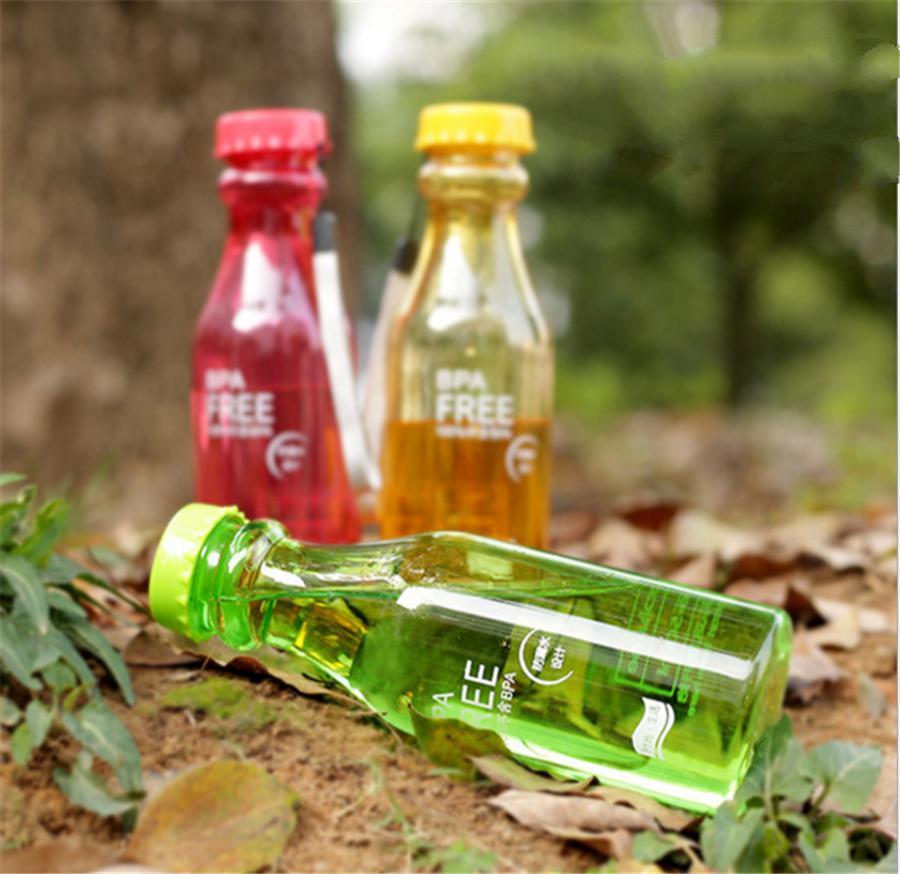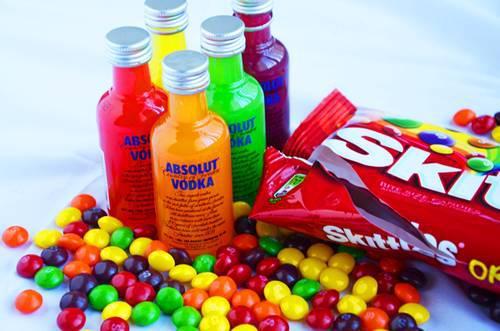The first image is the image on the left, the second image is the image on the right. Examine the images to the left and right. Is the description "The right image includes at least three upright bottles with multicolored candies on the surface next to them." accurate? Answer yes or no. Yes. 